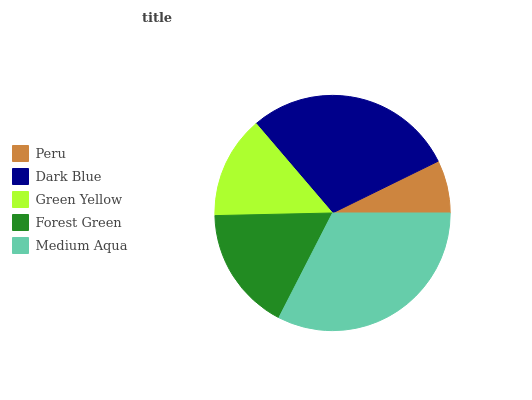Is Peru the minimum?
Answer yes or no. Yes. Is Medium Aqua the maximum?
Answer yes or no. Yes. Is Dark Blue the minimum?
Answer yes or no. No. Is Dark Blue the maximum?
Answer yes or no. No. Is Dark Blue greater than Peru?
Answer yes or no. Yes. Is Peru less than Dark Blue?
Answer yes or no. Yes. Is Peru greater than Dark Blue?
Answer yes or no. No. Is Dark Blue less than Peru?
Answer yes or no. No. Is Forest Green the high median?
Answer yes or no. Yes. Is Forest Green the low median?
Answer yes or no. Yes. Is Medium Aqua the high median?
Answer yes or no. No. Is Green Yellow the low median?
Answer yes or no. No. 